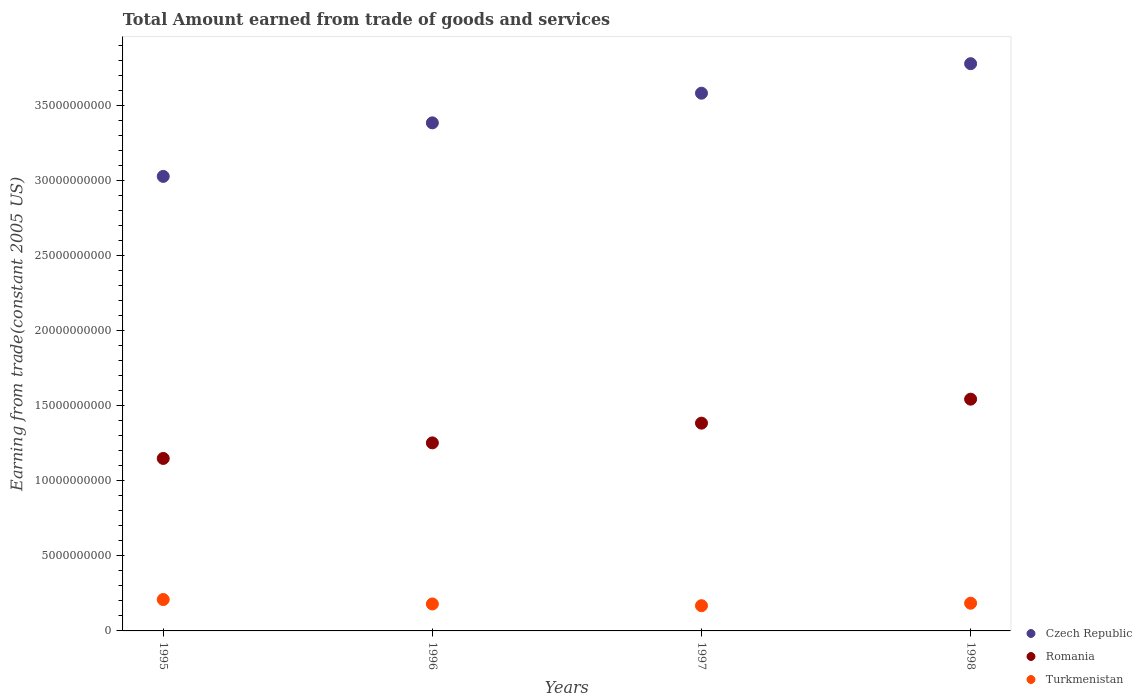What is the total amount earned by trading goods and services in Romania in 1996?
Provide a succinct answer. 1.25e+1. Across all years, what is the maximum total amount earned by trading goods and services in Romania?
Ensure brevity in your answer.  1.54e+1. Across all years, what is the minimum total amount earned by trading goods and services in Czech Republic?
Keep it short and to the point. 3.03e+1. In which year was the total amount earned by trading goods and services in Turkmenistan maximum?
Provide a short and direct response. 1995. What is the total total amount earned by trading goods and services in Turkmenistan in the graph?
Your answer should be very brief. 7.41e+09. What is the difference between the total amount earned by trading goods and services in Turkmenistan in 1995 and that in 1996?
Ensure brevity in your answer.  2.96e+08. What is the difference between the total amount earned by trading goods and services in Czech Republic in 1998 and the total amount earned by trading goods and services in Turkmenistan in 1996?
Offer a very short reply. 3.60e+1. What is the average total amount earned by trading goods and services in Romania per year?
Your answer should be compact. 1.33e+1. In the year 1996, what is the difference between the total amount earned by trading goods and services in Czech Republic and total amount earned by trading goods and services in Turkmenistan?
Your answer should be compact. 3.20e+1. What is the ratio of the total amount earned by trading goods and services in Czech Republic in 1996 to that in 1997?
Offer a terse response. 0.94. What is the difference between the highest and the second highest total amount earned by trading goods and services in Turkmenistan?
Ensure brevity in your answer.  2.45e+08. What is the difference between the highest and the lowest total amount earned by trading goods and services in Romania?
Give a very brief answer. 3.95e+09. In how many years, is the total amount earned by trading goods and services in Romania greater than the average total amount earned by trading goods and services in Romania taken over all years?
Offer a terse response. 2. Is the sum of the total amount earned by trading goods and services in Turkmenistan in 1995 and 1996 greater than the maximum total amount earned by trading goods and services in Czech Republic across all years?
Your answer should be very brief. No. Is the total amount earned by trading goods and services in Czech Republic strictly greater than the total amount earned by trading goods and services in Turkmenistan over the years?
Provide a short and direct response. Yes. What is the difference between two consecutive major ticks on the Y-axis?
Provide a succinct answer. 5.00e+09. Are the values on the major ticks of Y-axis written in scientific E-notation?
Offer a terse response. No. Does the graph contain grids?
Offer a terse response. No. Where does the legend appear in the graph?
Make the answer very short. Bottom right. What is the title of the graph?
Make the answer very short. Total Amount earned from trade of goods and services. Does "Ghana" appear as one of the legend labels in the graph?
Provide a succinct answer. No. What is the label or title of the Y-axis?
Offer a very short reply. Earning from trade(constant 2005 US). What is the Earning from trade(constant 2005 US) of Czech Republic in 1995?
Provide a succinct answer. 3.03e+1. What is the Earning from trade(constant 2005 US) of Romania in 1995?
Offer a very short reply. 1.15e+1. What is the Earning from trade(constant 2005 US) in Turkmenistan in 1995?
Your response must be concise. 2.09e+09. What is the Earning from trade(constant 2005 US) of Czech Republic in 1996?
Provide a succinct answer. 3.38e+1. What is the Earning from trade(constant 2005 US) in Romania in 1996?
Offer a terse response. 1.25e+1. What is the Earning from trade(constant 2005 US) of Turkmenistan in 1996?
Make the answer very short. 1.79e+09. What is the Earning from trade(constant 2005 US) in Czech Republic in 1997?
Provide a succinct answer. 3.58e+1. What is the Earning from trade(constant 2005 US) in Romania in 1997?
Provide a succinct answer. 1.38e+1. What is the Earning from trade(constant 2005 US) of Turkmenistan in 1997?
Keep it short and to the point. 1.68e+09. What is the Earning from trade(constant 2005 US) of Czech Republic in 1998?
Offer a terse response. 3.78e+1. What is the Earning from trade(constant 2005 US) of Romania in 1998?
Make the answer very short. 1.54e+1. What is the Earning from trade(constant 2005 US) of Turkmenistan in 1998?
Give a very brief answer. 1.84e+09. Across all years, what is the maximum Earning from trade(constant 2005 US) of Czech Republic?
Provide a short and direct response. 3.78e+1. Across all years, what is the maximum Earning from trade(constant 2005 US) of Romania?
Keep it short and to the point. 1.54e+1. Across all years, what is the maximum Earning from trade(constant 2005 US) of Turkmenistan?
Ensure brevity in your answer.  2.09e+09. Across all years, what is the minimum Earning from trade(constant 2005 US) of Czech Republic?
Offer a terse response. 3.03e+1. Across all years, what is the minimum Earning from trade(constant 2005 US) in Romania?
Provide a succinct answer. 1.15e+1. Across all years, what is the minimum Earning from trade(constant 2005 US) of Turkmenistan?
Your answer should be very brief. 1.68e+09. What is the total Earning from trade(constant 2005 US) of Czech Republic in the graph?
Your answer should be very brief. 1.38e+11. What is the total Earning from trade(constant 2005 US) in Romania in the graph?
Your response must be concise. 5.33e+1. What is the total Earning from trade(constant 2005 US) of Turkmenistan in the graph?
Provide a succinct answer. 7.41e+09. What is the difference between the Earning from trade(constant 2005 US) of Czech Republic in 1995 and that in 1996?
Provide a short and direct response. -3.56e+09. What is the difference between the Earning from trade(constant 2005 US) in Romania in 1995 and that in 1996?
Offer a very short reply. -1.04e+09. What is the difference between the Earning from trade(constant 2005 US) of Turkmenistan in 1995 and that in 1996?
Provide a succinct answer. 2.96e+08. What is the difference between the Earning from trade(constant 2005 US) in Czech Republic in 1995 and that in 1997?
Make the answer very short. -5.54e+09. What is the difference between the Earning from trade(constant 2005 US) in Romania in 1995 and that in 1997?
Give a very brief answer. -2.35e+09. What is the difference between the Earning from trade(constant 2005 US) of Turkmenistan in 1995 and that in 1997?
Your response must be concise. 4.11e+08. What is the difference between the Earning from trade(constant 2005 US) in Czech Republic in 1995 and that in 1998?
Your answer should be compact. -7.50e+09. What is the difference between the Earning from trade(constant 2005 US) in Romania in 1995 and that in 1998?
Keep it short and to the point. -3.95e+09. What is the difference between the Earning from trade(constant 2005 US) of Turkmenistan in 1995 and that in 1998?
Your response must be concise. 2.45e+08. What is the difference between the Earning from trade(constant 2005 US) in Czech Republic in 1996 and that in 1997?
Ensure brevity in your answer.  -1.97e+09. What is the difference between the Earning from trade(constant 2005 US) of Romania in 1996 and that in 1997?
Keep it short and to the point. -1.31e+09. What is the difference between the Earning from trade(constant 2005 US) in Turkmenistan in 1996 and that in 1997?
Provide a succinct answer. 1.15e+08. What is the difference between the Earning from trade(constant 2005 US) of Czech Republic in 1996 and that in 1998?
Make the answer very short. -3.94e+09. What is the difference between the Earning from trade(constant 2005 US) in Romania in 1996 and that in 1998?
Provide a succinct answer. -2.91e+09. What is the difference between the Earning from trade(constant 2005 US) of Turkmenistan in 1996 and that in 1998?
Offer a very short reply. -5.08e+07. What is the difference between the Earning from trade(constant 2005 US) in Czech Republic in 1997 and that in 1998?
Ensure brevity in your answer.  -1.97e+09. What is the difference between the Earning from trade(constant 2005 US) in Romania in 1997 and that in 1998?
Keep it short and to the point. -1.60e+09. What is the difference between the Earning from trade(constant 2005 US) in Turkmenistan in 1997 and that in 1998?
Offer a very short reply. -1.66e+08. What is the difference between the Earning from trade(constant 2005 US) of Czech Republic in 1995 and the Earning from trade(constant 2005 US) of Romania in 1996?
Your answer should be very brief. 1.77e+1. What is the difference between the Earning from trade(constant 2005 US) in Czech Republic in 1995 and the Earning from trade(constant 2005 US) in Turkmenistan in 1996?
Give a very brief answer. 2.85e+1. What is the difference between the Earning from trade(constant 2005 US) in Romania in 1995 and the Earning from trade(constant 2005 US) in Turkmenistan in 1996?
Offer a terse response. 9.69e+09. What is the difference between the Earning from trade(constant 2005 US) in Czech Republic in 1995 and the Earning from trade(constant 2005 US) in Romania in 1997?
Offer a very short reply. 1.64e+1. What is the difference between the Earning from trade(constant 2005 US) in Czech Republic in 1995 and the Earning from trade(constant 2005 US) in Turkmenistan in 1997?
Offer a very short reply. 2.86e+1. What is the difference between the Earning from trade(constant 2005 US) in Romania in 1995 and the Earning from trade(constant 2005 US) in Turkmenistan in 1997?
Make the answer very short. 9.80e+09. What is the difference between the Earning from trade(constant 2005 US) in Czech Republic in 1995 and the Earning from trade(constant 2005 US) in Romania in 1998?
Your response must be concise. 1.48e+1. What is the difference between the Earning from trade(constant 2005 US) of Czech Republic in 1995 and the Earning from trade(constant 2005 US) of Turkmenistan in 1998?
Offer a very short reply. 2.84e+1. What is the difference between the Earning from trade(constant 2005 US) of Romania in 1995 and the Earning from trade(constant 2005 US) of Turkmenistan in 1998?
Ensure brevity in your answer.  9.64e+09. What is the difference between the Earning from trade(constant 2005 US) of Czech Republic in 1996 and the Earning from trade(constant 2005 US) of Romania in 1997?
Provide a succinct answer. 2.00e+1. What is the difference between the Earning from trade(constant 2005 US) in Czech Republic in 1996 and the Earning from trade(constant 2005 US) in Turkmenistan in 1997?
Provide a short and direct response. 3.21e+1. What is the difference between the Earning from trade(constant 2005 US) of Romania in 1996 and the Earning from trade(constant 2005 US) of Turkmenistan in 1997?
Keep it short and to the point. 1.08e+1. What is the difference between the Earning from trade(constant 2005 US) in Czech Republic in 1996 and the Earning from trade(constant 2005 US) in Romania in 1998?
Ensure brevity in your answer.  1.84e+1. What is the difference between the Earning from trade(constant 2005 US) in Czech Republic in 1996 and the Earning from trade(constant 2005 US) in Turkmenistan in 1998?
Provide a short and direct response. 3.20e+1. What is the difference between the Earning from trade(constant 2005 US) of Romania in 1996 and the Earning from trade(constant 2005 US) of Turkmenistan in 1998?
Ensure brevity in your answer.  1.07e+1. What is the difference between the Earning from trade(constant 2005 US) in Czech Republic in 1997 and the Earning from trade(constant 2005 US) in Romania in 1998?
Offer a very short reply. 2.04e+1. What is the difference between the Earning from trade(constant 2005 US) in Czech Republic in 1997 and the Earning from trade(constant 2005 US) in Turkmenistan in 1998?
Give a very brief answer. 3.40e+1. What is the difference between the Earning from trade(constant 2005 US) in Romania in 1997 and the Earning from trade(constant 2005 US) in Turkmenistan in 1998?
Make the answer very short. 1.20e+1. What is the average Earning from trade(constant 2005 US) of Czech Republic per year?
Offer a terse response. 3.44e+1. What is the average Earning from trade(constant 2005 US) of Romania per year?
Make the answer very short. 1.33e+1. What is the average Earning from trade(constant 2005 US) in Turkmenistan per year?
Provide a succinct answer. 1.85e+09. In the year 1995, what is the difference between the Earning from trade(constant 2005 US) in Czech Republic and Earning from trade(constant 2005 US) in Romania?
Keep it short and to the point. 1.88e+1. In the year 1995, what is the difference between the Earning from trade(constant 2005 US) of Czech Republic and Earning from trade(constant 2005 US) of Turkmenistan?
Provide a short and direct response. 2.82e+1. In the year 1995, what is the difference between the Earning from trade(constant 2005 US) of Romania and Earning from trade(constant 2005 US) of Turkmenistan?
Your answer should be compact. 9.39e+09. In the year 1996, what is the difference between the Earning from trade(constant 2005 US) of Czech Republic and Earning from trade(constant 2005 US) of Romania?
Make the answer very short. 2.13e+1. In the year 1996, what is the difference between the Earning from trade(constant 2005 US) of Czech Republic and Earning from trade(constant 2005 US) of Turkmenistan?
Make the answer very short. 3.20e+1. In the year 1996, what is the difference between the Earning from trade(constant 2005 US) of Romania and Earning from trade(constant 2005 US) of Turkmenistan?
Offer a terse response. 1.07e+1. In the year 1997, what is the difference between the Earning from trade(constant 2005 US) in Czech Republic and Earning from trade(constant 2005 US) in Romania?
Provide a succinct answer. 2.20e+1. In the year 1997, what is the difference between the Earning from trade(constant 2005 US) in Czech Republic and Earning from trade(constant 2005 US) in Turkmenistan?
Your answer should be compact. 3.41e+1. In the year 1997, what is the difference between the Earning from trade(constant 2005 US) in Romania and Earning from trade(constant 2005 US) in Turkmenistan?
Offer a very short reply. 1.22e+1. In the year 1998, what is the difference between the Earning from trade(constant 2005 US) in Czech Republic and Earning from trade(constant 2005 US) in Romania?
Your answer should be very brief. 2.23e+1. In the year 1998, what is the difference between the Earning from trade(constant 2005 US) of Czech Republic and Earning from trade(constant 2005 US) of Turkmenistan?
Provide a short and direct response. 3.59e+1. In the year 1998, what is the difference between the Earning from trade(constant 2005 US) in Romania and Earning from trade(constant 2005 US) in Turkmenistan?
Keep it short and to the point. 1.36e+1. What is the ratio of the Earning from trade(constant 2005 US) in Czech Republic in 1995 to that in 1996?
Your answer should be very brief. 0.89. What is the ratio of the Earning from trade(constant 2005 US) in Romania in 1995 to that in 1996?
Offer a very short reply. 0.92. What is the ratio of the Earning from trade(constant 2005 US) in Turkmenistan in 1995 to that in 1996?
Your answer should be compact. 1.17. What is the ratio of the Earning from trade(constant 2005 US) in Czech Republic in 1995 to that in 1997?
Give a very brief answer. 0.85. What is the ratio of the Earning from trade(constant 2005 US) of Romania in 1995 to that in 1997?
Give a very brief answer. 0.83. What is the ratio of the Earning from trade(constant 2005 US) in Turkmenistan in 1995 to that in 1997?
Make the answer very short. 1.24. What is the ratio of the Earning from trade(constant 2005 US) of Czech Republic in 1995 to that in 1998?
Your answer should be compact. 0.8. What is the ratio of the Earning from trade(constant 2005 US) in Romania in 1995 to that in 1998?
Offer a very short reply. 0.74. What is the ratio of the Earning from trade(constant 2005 US) of Turkmenistan in 1995 to that in 1998?
Your answer should be very brief. 1.13. What is the ratio of the Earning from trade(constant 2005 US) of Czech Republic in 1996 to that in 1997?
Make the answer very short. 0.94. What is the ratio of the Earning from trade(constant 2005 US) in Romania in 1996 to that in 1997?
Keep it short and to the point. 0.91. What is the ratio of the Earning from trade(constant 2005 US) of Turkmenistan in 1996 to that in 1997?
Make the answer very short. 1.07. What is the ratio of the Earning from trade(constant 2005 US) in Czech Republic in 1996 to that in 1998?
Make the answer very short. 0.9. What is the ratio of the Earning from trade(constant 2005 US) in Romania in 1996 to that in 1998?
Keep it short and to the point. 0.81. What is the ratio of the Earning from trade(constant 2005 US) of Turkmenistan in 1996 to that in 1998?
Provide a short and direct response. 0.97. What is the ratio of the Earning from trade(constant 2005 US) in Czech Republic in 1997 to that in 1998?
Your response must be concise. 0.95. What is the ratio of the Earning from trade(constant 2005 US) of Romania in 1997 to that in 1998?
Make the answer very short. 0.9. What is the ratio of the Earning from trade(constant 2005 US) of Turkmenistan in 1997 to that in 1998?
Ensure brevity in your answer.  0.91. What is the difference between the highest and the second highest Earning from trade(constant 2005 US) in Czech Republic?
Keep it short and to the point. 1.97e+09. What is the difference between the highest and the second highest Earning from trade(constant 2005 US) in Romania?
Ensure brevity in your answer.  1.60e+09. What is the difference between the highest and the second highest Earning from trade(constant 2005 US) of Turkmenistan?
Provide a succinct answer. 2.45e+08. What is the difference between the highest and the lowest Earning from trade(constant 2005 US) of Czech Republic?
Provide a succinct answer. 7.50e+09. What is the difference between the highest and the lowest Earning from trade(constant 2005 US) in Romania?
Ensure brevity in your answer.  3.95e+09. What is the difference between the highest and the lowest Earning from trade(constant 2005 US) in Turkmenistan?
Provide a short and direct response. 4.11e+08. 